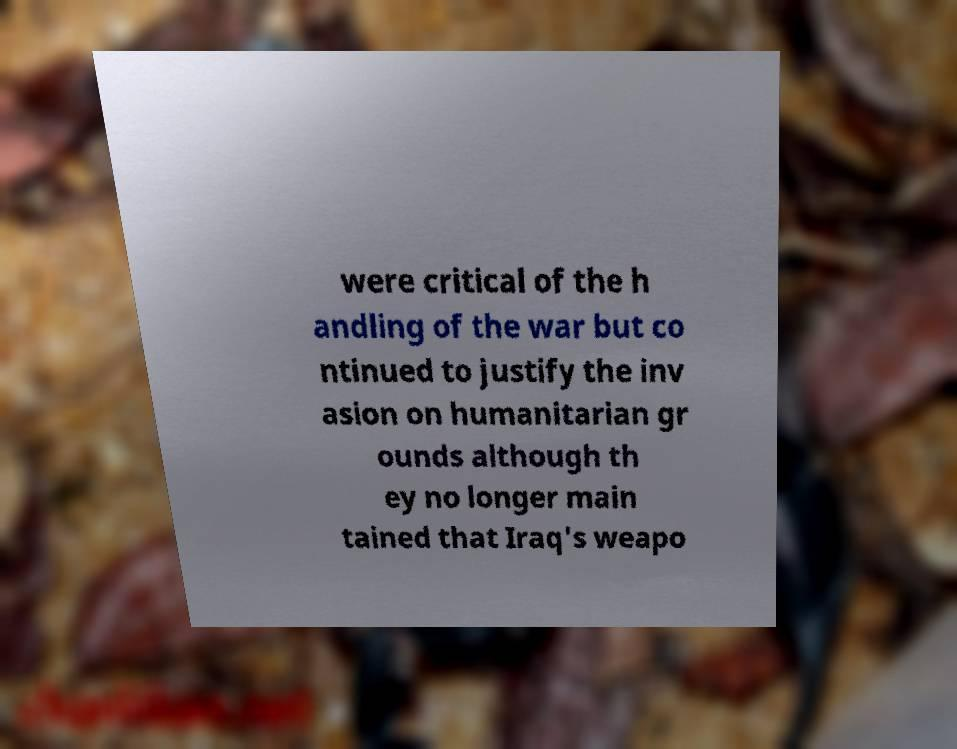Could you assist in decoding the text presented in this image and type it out clearly? were critical of the h andling of the war but co ntinued to justify the inv asion on humanitarian gr ounds although th ey no longer main tained that Iraq's weapo 